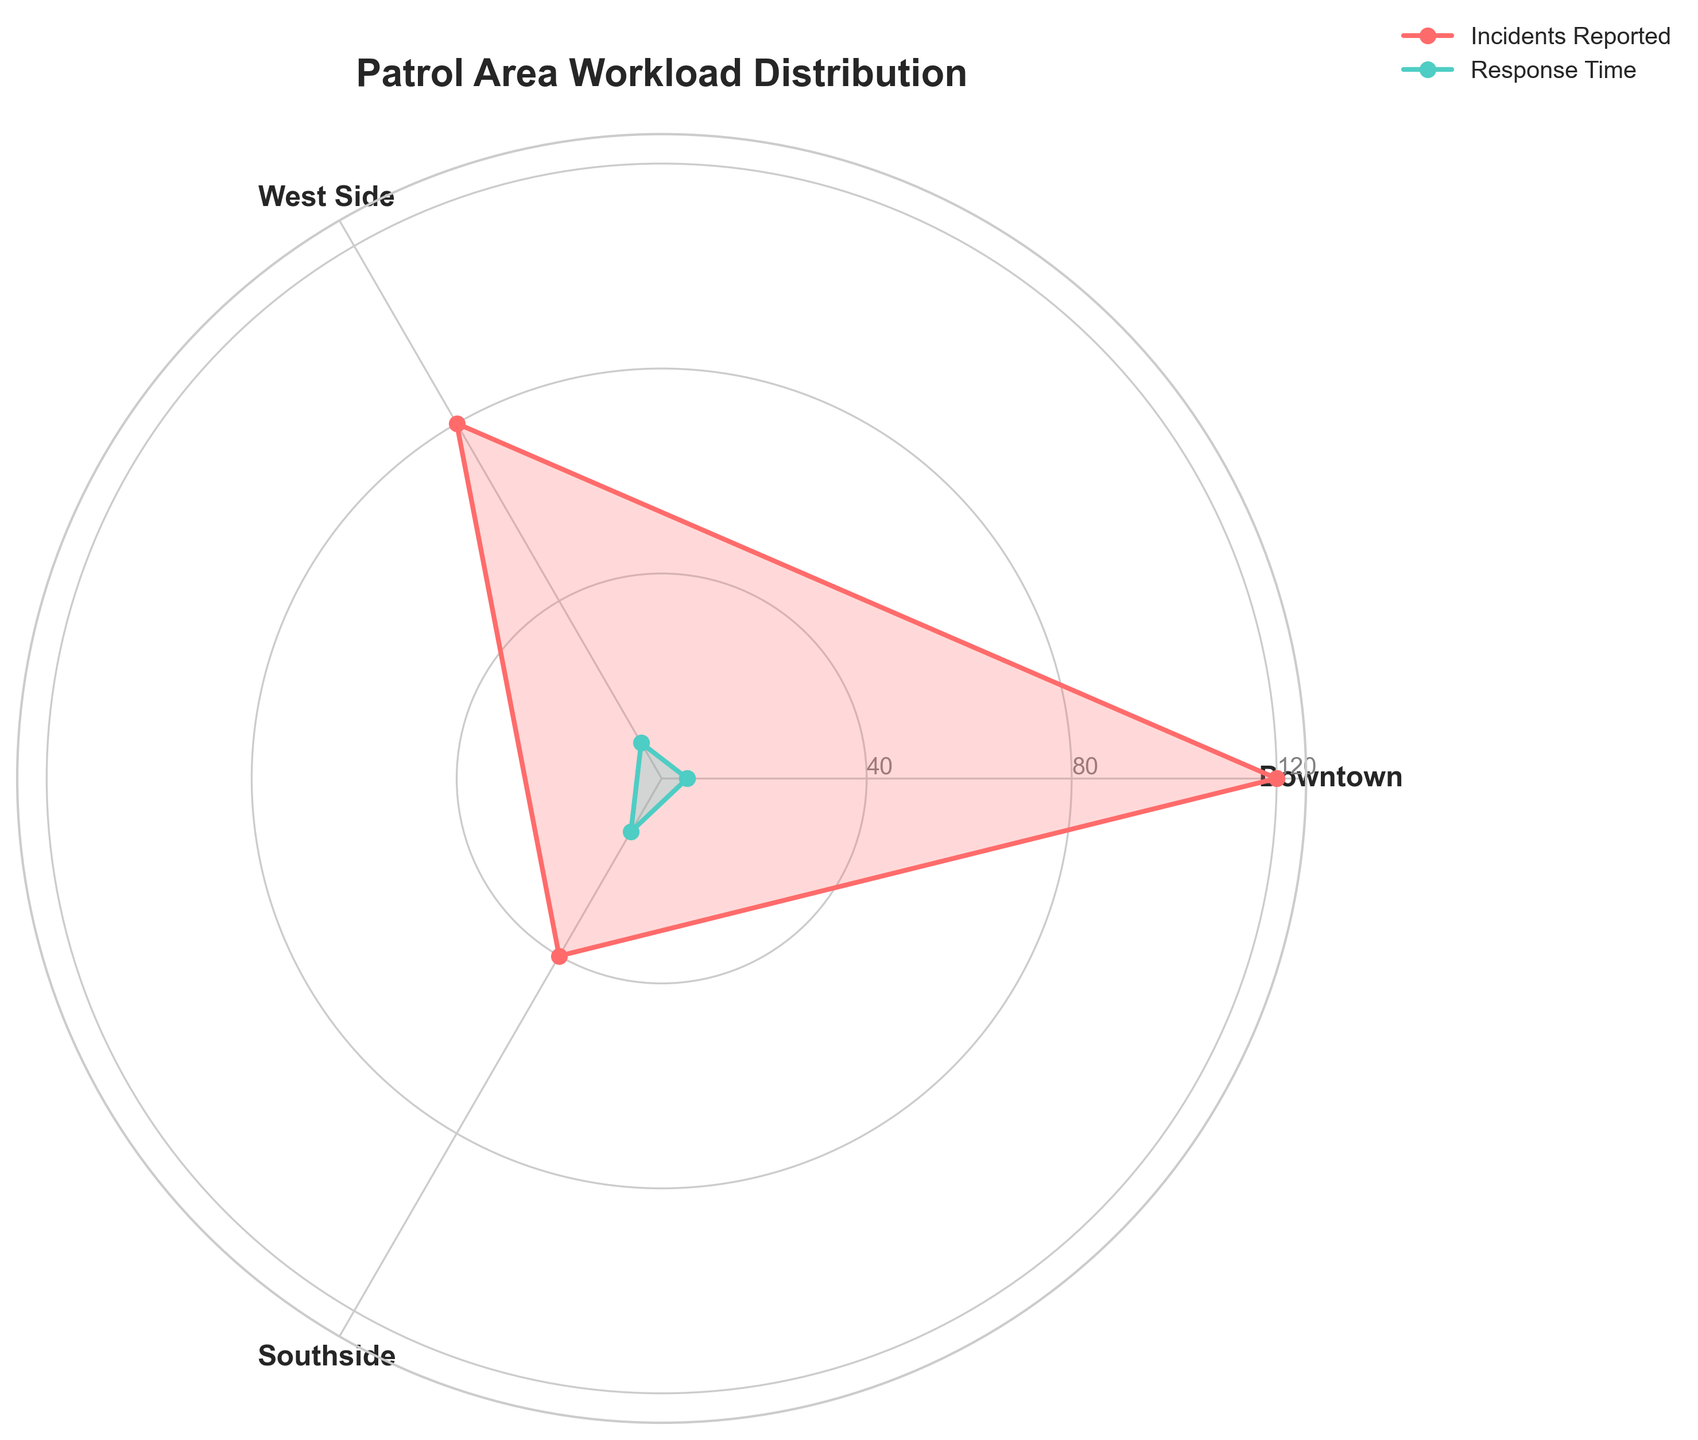What is the title of the chart? The title of the chart is located at the top and usually describes the content of the figure.
Answer: "Patrol Area Workload Distribution" What are the three patrol areas mentioned in the chart? The patrol areas are listed as labels around the chart.
Answer: Downtown, West Side, Southside Which patrol area has the highest number of incidents reported? By observing the length of the 'Incidents Reported' section, the area with the longest section is the one with the highest number of incidents. Downtown has the longest section.
Answer: Downtown Which patrol area has the shortest response time? The 'Response Time' sections can be compared by their length. Downtown has the shortest section for 'Response Time.'
Answer: Downtown How many incidents were reported in the Southside patrol area? The length of the 'Incidents Reported' section corresponding to Southside can be matched with the y-axis ticks, showing 40 incidents.
Answer: 40 Compare the incidents reported in the Downtown and West Side areas. By comparing the lengths of the 'Incidents Reported' sections, Downtown has more incidents than West Side. Downtown is at 120 and West Side is at 80 incidents.
Answer: Downtown has more incidents (120 vs. 80) How does the response time in West Side compare to Southside? Observing the lengths of the 'Response Time' sections, West Side has a shorter response time than Southside. West Side is at 8 and Southside at 12.
Answer: West Side has a shorter response time (8 vs. 12) What is the range of incident reports across all patrol areas? The range is calculated as the difference between the maximum and minimum incident reports. Downtown (120) - Southside (40) = 80.
Answer: 80 Which patrol area exhibits the maximum response time? Observing the lengths of the 'Response Time' sections, Southside has the longest section.
Answer: Southside What is the average response time across all patrol areas? The average is calculated by summing the response times (5 + 8 + 12) and dividing by the number of areas (3). (5 + 8 + 12) / 3 = 25 / 3.
Answer: Approximately 8.3 minutes 